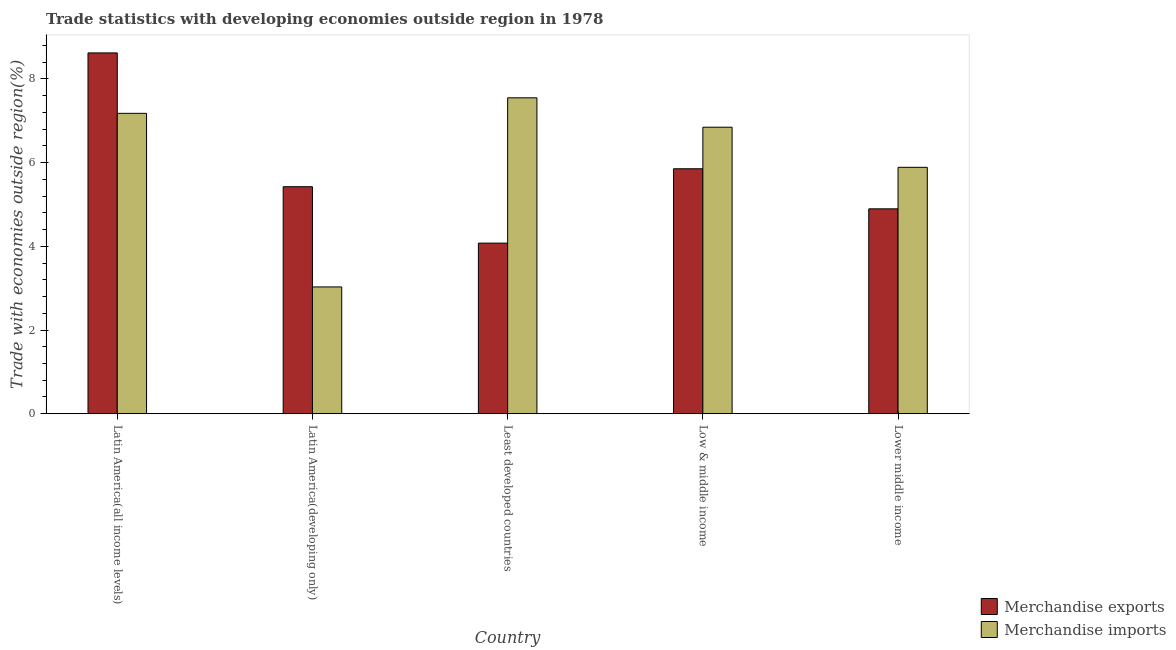How many different coloured bars are there?
Provide a short and direct response. 2. Are the number of bars per tick equal to the number of legend labels?
Your answer should be very brief. Yes. Are the number of bars on each tick of the X-axis equal?
Your answer should be very brief. Yes. How many bars are there on the 3rd tick from the left?
Your answer should be compact. 2. What is the label of the 5th group of bars from the left?
Offer a terse response. Lower middle income. What is the merchandise exports in Latin America(all income levels)?
Provide a short and direct response. 8.62. Across all countries, what is the maximum merchandise imports?
Keep it short and to the point. 7.55. Across all countries, what is the minimum merchandise imports?
Provide a short and direct response. 3.03. In which country was the merchandise exports maximum?
Give a very brief answer. Latin America(all income levels). In which country was the merchandise imports minimum?
Provide a succinct answer. Latin America(developing only). What is the total merchandise exports in the graph?
Keep it short and to the point. 28.87. What is the difference between the merchandise imports in Latin America(all income levels) and that in Least developed countries?
Provide a succinct answer. -0.37. What is the difference between the merchandise imports in Latin America(all income levels) and the merchandise exports in Latin America(developing only)?
Ensure brevity in your answer.  1.75. What is the average merchandise imports per country?
Your answer should be very brief. 6.1. What is the difference between the merchandise exports and merchandise imports in Lower middle income?
Your answer should be very brief. -0.99. What is the ratio of the merchandise exports in Latin America(all income levels) to that in Latin America(developing only)?
Keep it short and to the point. 1.59. Is the merchandise imports in Latin America(all income levels) less than that in Least developed countries?
Your answer should be very brief. Yes. Is the difference between the merchandise imports in Latin America(all income levels) and Lower middle income greater than the difference between the merchandise exports in Latin America(all income levels) and Lower middle income?
Ensure brevity in your answer.  No. What is the difference between the highest and the second highest merchandise exports?
Offer a very short reply. 2.77. What is the difference between the highest and the lowest merchandise exports?
Ensure brevity in your answer.  4.54. What does the 1st bar from the right in Lower middle income represents?
Provide a short and direct response. Merchandise imports. Are all the bars in the graph horizontal?
Offer a terse response. No. How many countries are there in the graph?
Keep it short and to the point. 5. What is the difference between two consecutive major ticks on the Y-axis?
Ensure brevity in your answer.  2. Are the values on the major ticks of Y-axis written in scientific E-notation?
Ensure brevity in your answer.  No. Does the graph contain any zero values?
Provide a short and direct response. No. Where does the legend appear in the graph?
Make the answer very short. Bottom right. How many legend labels are there?
Your answer should be very brief. 2. What is the title of the graph?
Offer a terse response. Trade statistics with developing economies outside region in 1978. Does "GDP" appear as one of the legend labels in the graph?
Your answer should be compact. No. What is the label or title of the X-axis?
Offer a very short reply. Country. What is the label or title of the Y-axis?
Provide a succinct answer. Trade with economies outside region(%). What is the Trade with economies outside region(%) of Merchandise exports in Latin America(all income levels)?
Provide a succinct answer. 8.62. What is the Trade with economies outside region(%) of Merchandise imports in Latin America(all income levels)?
Give a very brief answer. 7.18. What is the Trade with economies outside region(%) in Merchandise exports in Latin America(developing only)?
Keep it short and to the point. 5.42. What is the Trade with economies outside region(%) in Merchandise imports in Latin America(developing only)?
Offer a terse response. 3.03. What is the Trade with economies outside region(%) in Merchandise exports in Least developed countries?
Offer a terse response. 4.08. What is the Trade with economies outside region(%) of Merchandise imports in Least developed countries?
Provide a succinct answer. 7.55. What is the Trade with economies outside region(%) of Merchandise exports in Low & middle income?
Offer a very short reply. 5.85. What is the Trade with economies outside region(%) of Merchandise imports in Low & middle income?
Keep it short and to the point. 6.85. What is the Trade with economies outside region(%) in Merchandise exports in Lower middle income?
Make the answer very short. 4.9. What is the Trade with economies outside region(%) of Merchandise imports in Lower middle income?
Your answer should be compact. 5.89. Across all countries, what is the maximum Trade with economies outside region(%) in Merchandise exports?
Ensure brevity in your answer.  8.62. Across all countries, what is the maximum Trade with economies outside region(%) in Merchandise imports?
Keep it short and to the point. 7.55. Across all countries, what is the minimum Trade with economies outside region(%) of Merchandise exports?
Your response must be concise. 4.08. Across all countries, what is the minimum Trade with economies outside region(%) of Merchandise imports?
Ensure brevity in your answer.  3.03. What is the total Trade with economies outside region(%) of Merchandise exports in the graph?
Offer a terse response. 28.87. What is the total Trade with economies outside region(%) in Merchandise imports in the graph?
Provide a short and direct response. 30.49. What is the difference between the Trade with economies outside region(%) in Merchandise exports in Latin America(all income levels) and that in Latin America(developing only)?
Ensure brevity in your answer.  3.2. What is the difference between the Trade with economies outside region(%) in Merchandise imports in Latin America(all income levels) and that in Latin America(developing only)?
Provide a short and direct response. 4.15. What is the difference between the Trade with economies outside region(%) of Merchandise exports in Latin America(all income levels) and that in Least developed countries?
Keep it short and to the point. 4.54. What is the difference between the Trade with economies outside region(%) in Merchandise imports in Latin America(all income levels) and that in Least developed countries?
Provide a short and direct response. -0.37. What is the difference between the Trade with economies outside region(%) of Merchandise exports in Latin America(all income levels) and that in Low & middle income?
Your response must be concise. 2.77. What is the difference between the Trade with economies outside region(%) of Merchandise imports in Latin America(all income levels) and that in Low & middle income?
Provide a short and direct response. 0.33. What is the difference between the Trade with economies outside region(%) in Merchandise exports in Latin America(all income levels) and that in Lower middle income?
Make the answer very short. 3.72. What is the difference between the Trade with economies outside region(%) in Merchandise imports in Latin America(all income levels) and that in Lower middle income?
Your answer should be very brief. 1.29. What is the difference between the Trade with economies outside region(%) in Merchandise exports in Latin America(developing only) and that in Least developed countries?
Keep it short and to the point. 1.35. What is the difference between the Trade with economies outside region(%) of Merchandise imports in Latin America(developing only) and that in Least developed countries?
Offer a very short reply. -4.52. What is the difference between the Trade with economies outside region(%) of Merchandise exports in Latin America(developing only) and that in Low & middle income?
Provide a short and direct response. -0.43. What is the difference between the Trade with economies outside region(%) of Merchandise imports in Latin America(developing only) and that in Low & middle income?
Offer a terse response. -3.82. What is the difference between the Trade with economies outside region(%) of Merchandise exports in Latin America(developing only) and that in Lower middle income?
Your answer should be compact. 0.53. What is the difference between the Trade with economies outside region(%) in Merchandise imports in Latin America(developing only) and that in Lower middle income?
Ensure brevity in your answer.  -2.86. What is the difference between the Trade with economies outside region(%) of Merchandise exports in Least developed countries and that in Low & middle income?
Make the answer very short. -1.78. What is the difference between the Trade with economies outside region(%) of Merchandise imports in Least developed countries and that in Low & middle income?
Offer a terse response. 0.7. What is the difference between the Trade with economies outside region(%) of Merchandise exports in Least developed countries and that in Lower middle income?
Give a very brief answer. -0.82. What is the difference between the Trade with economies outside region(%) of Merchandise imports in Least developed countries and that in Lower middle income?
Give a very brief answer. 1.66. What is the difference between the Trade with economies outside region(%) in Merchandise exports in Low & middle income and that in Lower middle income?
Your answer should be compact. 0.96. What is the difference between the Trade with economies outside region(%) of Merchandise imports in Low & middle income and that in Lower middle income?
Offer a very short reply. 0.96. What is the difference between the Trade with economies outside region(%) of Merchandise exports in Latin America(all income levels) and the Trade with economies outside region(%) of Merchandise imports in Latin America(developing only)?
Offer a very short reply. 5.59. What is the difference between the Trade with economies outside region(%) of Merchandise exports in Latin America(all income levels) and the Trade with economies outside region(%) of Merchandise imports in Least developed countries?
Your answer should be compact. 1.07. What is the difference between the Trade with economies outside region(%) in Merchandise exports in Latin America(all income levels) and the Trade with economies outside region(%) in Merchandise imports in Low & middle income?
Offer a very short reply. 1.77. What is the difference between the Trade with economies outside region(%) in Merchandise exports in Latin America(all income levels) and the Trade with economies outside region(%) in Merchandise imports in Lower middle income?
Your answer should be very brief. 2.73. What is the difference between the Trade with economies outside region(%) of Merchandise exports in Latin America(developing only) and the Trade with economies outside region(%) of Merchandise imports in Least developed countries?
Give a very brief answer. -2.12. What is the difference between the Trade with economies outside region(%) of Merchandise exports in Latin America(developing only) and the Trade with economies outside region(%) of Merchandise imports in Low & middle income?
Provide a short and direct response. -1.42. What is the difference between the Trade with economies outside region(%) in Merchandise exports in Latin America(developing only) and the Trade with economies outside region(%) in Merchandise imports in Lower middle income?
Offer a terse response. -0.46. What is the difference between the Trade with economies outside region(%) in Merchandise exports in Least developed countries and the Trade with economies outside region(%) in Merchandise imports in Low & middle income?
Make the answer very short. -2.77. What is the difference between the Trade with economies outside region(%) of Merchandise exports in Least developed countries and the Trade with economies outside region(%) of Merchandise imports in Lower middle income?
Give a very brief answer. -1.81. What is the difference between the Trade with economies outside region(%) in Merchandise exports in Low & middle income and the Trade with economies outside region(%) in Merchandise imports in Lower middle income?
Provide a succinct answer. -0.03. What is the average Trade with economies outside region(%) in Merchandise exports per country?
Make the answer very short. 5.77. What is the average Trade with economies outside region(%) of Merchandise imports per country?
Offer a very short reply. 6.1. What is the difference between the Trade with economies outside region(%) in Merchandise exports and Trade with economies outside region(%) in Merchandise imports in Latin America(all income levels)?
Make the answer very short. 1.44. What is the difference between the Trade with economies outside region(%) in Merchandise exports and Trade with economies outside region(%) in Merchandise imports in Latin America(developing only)?
Offer a terse response. 2.39. What is the difference between the Trade with economies outside region(%) of Merchandise exports and Trade with economies outside region(%) of Merchandise imports in Least developed countries?
Ensure brevity in your answer.  -3.47. What is the difference between the Trade with economies outside region(%) in Merchandise exports and Trade with economies outside region(%) in Merchandise imports in Low & middle income?
Keep it short and to the point. -0.99. What is the difference between the Trade with economies outside region(%) of Merchandise exports and Trade with economies outside region(%) of Merchandise imports in Lower middle income?
Offer a very short reply. -0.99. What is the ratio of the Trade with economies outside region(%) of Merchandise exports in Latin America(all income levels) to that in Latin America(developing only)?
Ensure brevity in your answer.  1.59. What is the ratio of the Trade with economies outside region(%) in Merchandise imports in Latin America(all income levels) to that in Latin America(developing only)?
Offer a terse response. 2.37. What is the ratio of the Trade with economies outside region(%) of Merchandise exports in Latin America(all income levels) to that in Least developed countries?
Your response must be concise. 2.11. What is the ratio of the Trade with economies outside region(%) in Merchandise imports in Latin America(all income levels) to that in Least developed countries?
Offer a very short reply. 0.95. What is the ratio of the Trade with economies outside region(%) in Merchandise exports in Latin America(all income levels) to that in Low & middle income?
Give a very brief answer. 1.47. What is the ratio of the Trade with economies outside region(%) in Merchandise imports in Latin America(all income levels) to that in Low & middle income?
Offer a terse response. 1.05. What is the ratio of the Trade with economies outside region(%) in Merchandise exports in Latin America(all income levels) to that in Lower middle income?
Your answer should be compact. 1.76. What is the ratio of the Trade with economies outside region(%) in Merchandise imports in Latin America(all income levels) to that in Lower middle income?
Ensure brevity in your answer.  1.22. What is the ratio of the Trade with economies outside region(%) of Merchandise exports in Latin America(developing only) to that in Least developed countries?
Keep it short and to the point. 1.33. What is the ratio of the Trade with economies outside region(%) of Merchandise imports in Latin America(developing only) to that in Least developed countries?
Give a very brief answer. 0.4. What is the ratio of the Trade with economies outside region(%) in Merchandise exports in Latin America(developing only) to that in Low & middle income?
Offer a terse response. 0.93. What is the ratio of the Trade with economies outside region(%) in Merchandise imports in Latin America(developing only) to that in Low & middle income?
Your answer should be compact. 0.44. What is the ratio of the Trade with economies outside region(%) in Merchandise exports in Latin America(developing only) to that in Lower middle income?
Your answer should be very brief. 1.11. What is the ratio of the Trade with economies outside region(%) of Merchandise imports in Latin America(developing only) to that in Lower middle income?
Offer a terse response. 0.51. What is the ratio of the Trade with economies outside region(%) of Merchandise exports in Least developed countries to that in Low & middle income?
Keep it short and to the point. 0.7. What is the ratio of the Trade with economies outside region(%) in Merchandise imports in Least developed countries to that in Low & middle income?
Keep it short and to the point. 1.1. What is the ratio of the Trade with economies outside region(%) of Merchandise exports in Least developed countries to that in Lower middle income?
Offer a terse response. 0.83. What is the ratio of the Trade with economies outside region(%) in Merchandise imports in Least developed countries to that in Lower middle income?
Provide a short and direct response. 1.28. What is the ratio of the Trade with economies outside region(%) in Merchandise exports in Low & middle income to that in Lower middle income?
Offer a terse response. 1.2. What is the ratio of the Trade with economies outside region(%) of Merchandise imports in Low & middle income to that in Lower middle income?
Your answer should be very brief. 1.16. What is the difference between the highest and the second highest Trade with economies outside region(%) of Merchandise exports?
Give a very brief answer. 2.77. What is the difference between the highest and the second highest Trade with economies outside region(%) of Merchandise imports?
Give a very brief answer. 0.37. What is the difference between the highest and the lowest Trade with economies outside region(%) of Merchandise exports?
Provide a short and direct response. 4.54. What is the difference between the highest and the lowest Trade with economies outside region(%) in Merchandise imports?
Ensure brevity in your answer.  4.52. 